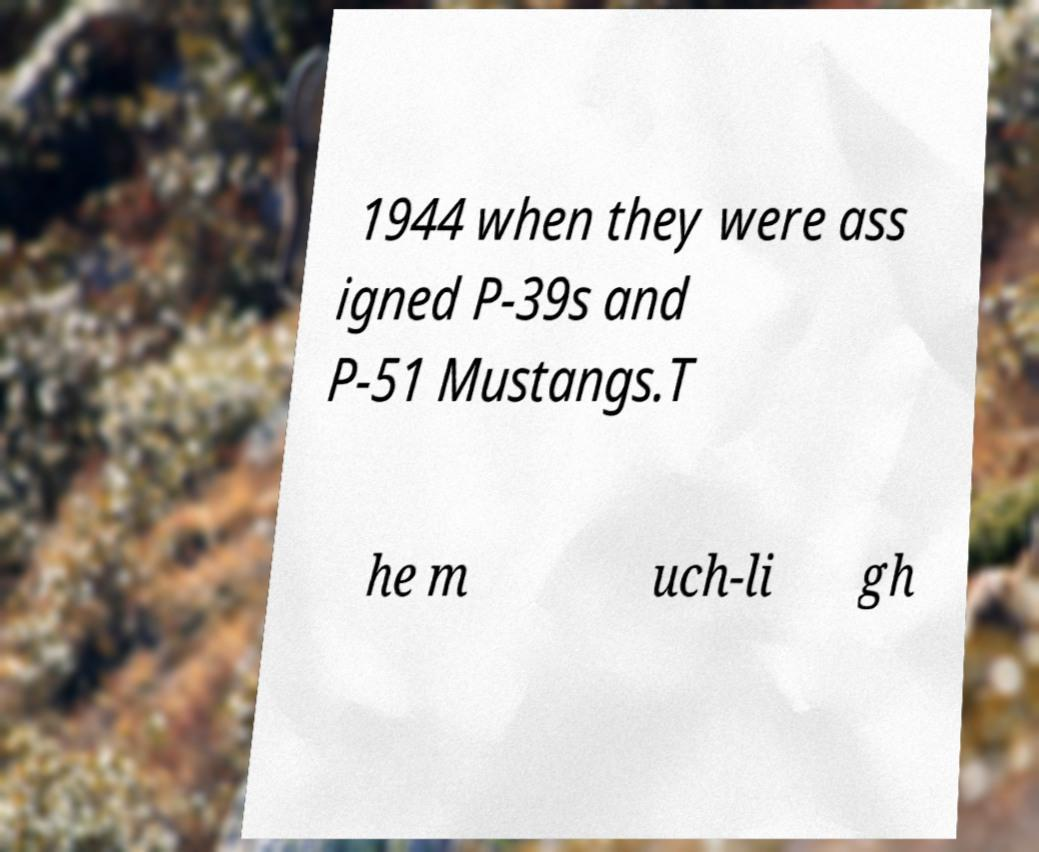For documentation purposes, I need the text within this image transcribed. Could you provide that? 1944 when they were ass igned P-39s and P-51 Mustangs.T he m uch-li gh 